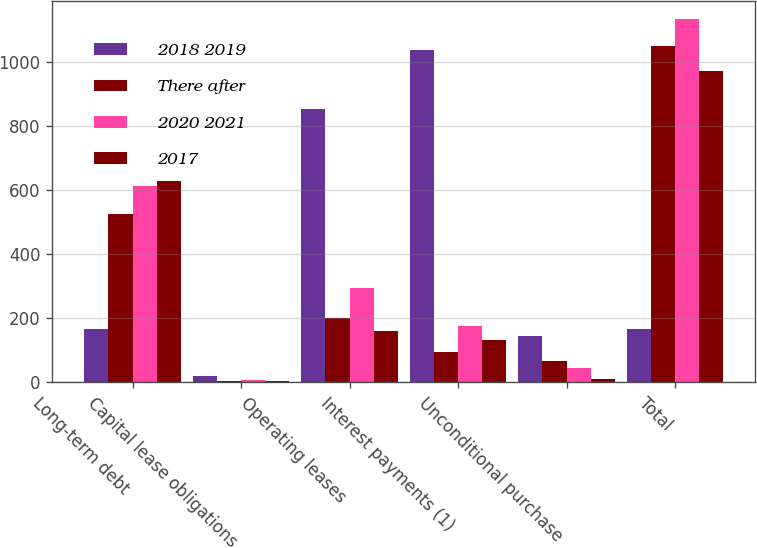Convert chart. <chart><loc_0><loc_0><loc_500><loc_500><stacked_bar_chart><ecel><fcel>Long-term debt<fcel>Capital lease obligations<fcel>Operating leases<fcel>Interest payments (1)<fcel>Unconditional purchase<fcel>Total<nl><fcel>2018 2019<fcel>167<fcel>18<fcel>854<fcel>1038<fcel>144<fcel>167<nl><fcel>There after<fcel>526<fcel>4<fcel>200<fcel>95<fcel>66<fcel>1049<nl><fcel>2020 2021<fcel>612<fcel>6<fcel>295<fcel>175<fcel>45<fcel>1133<nl><fcel>2017<fcel>627<fcel>3<fcel>159<fcel>133<fcel>11<fcel>971<nl></chart> 